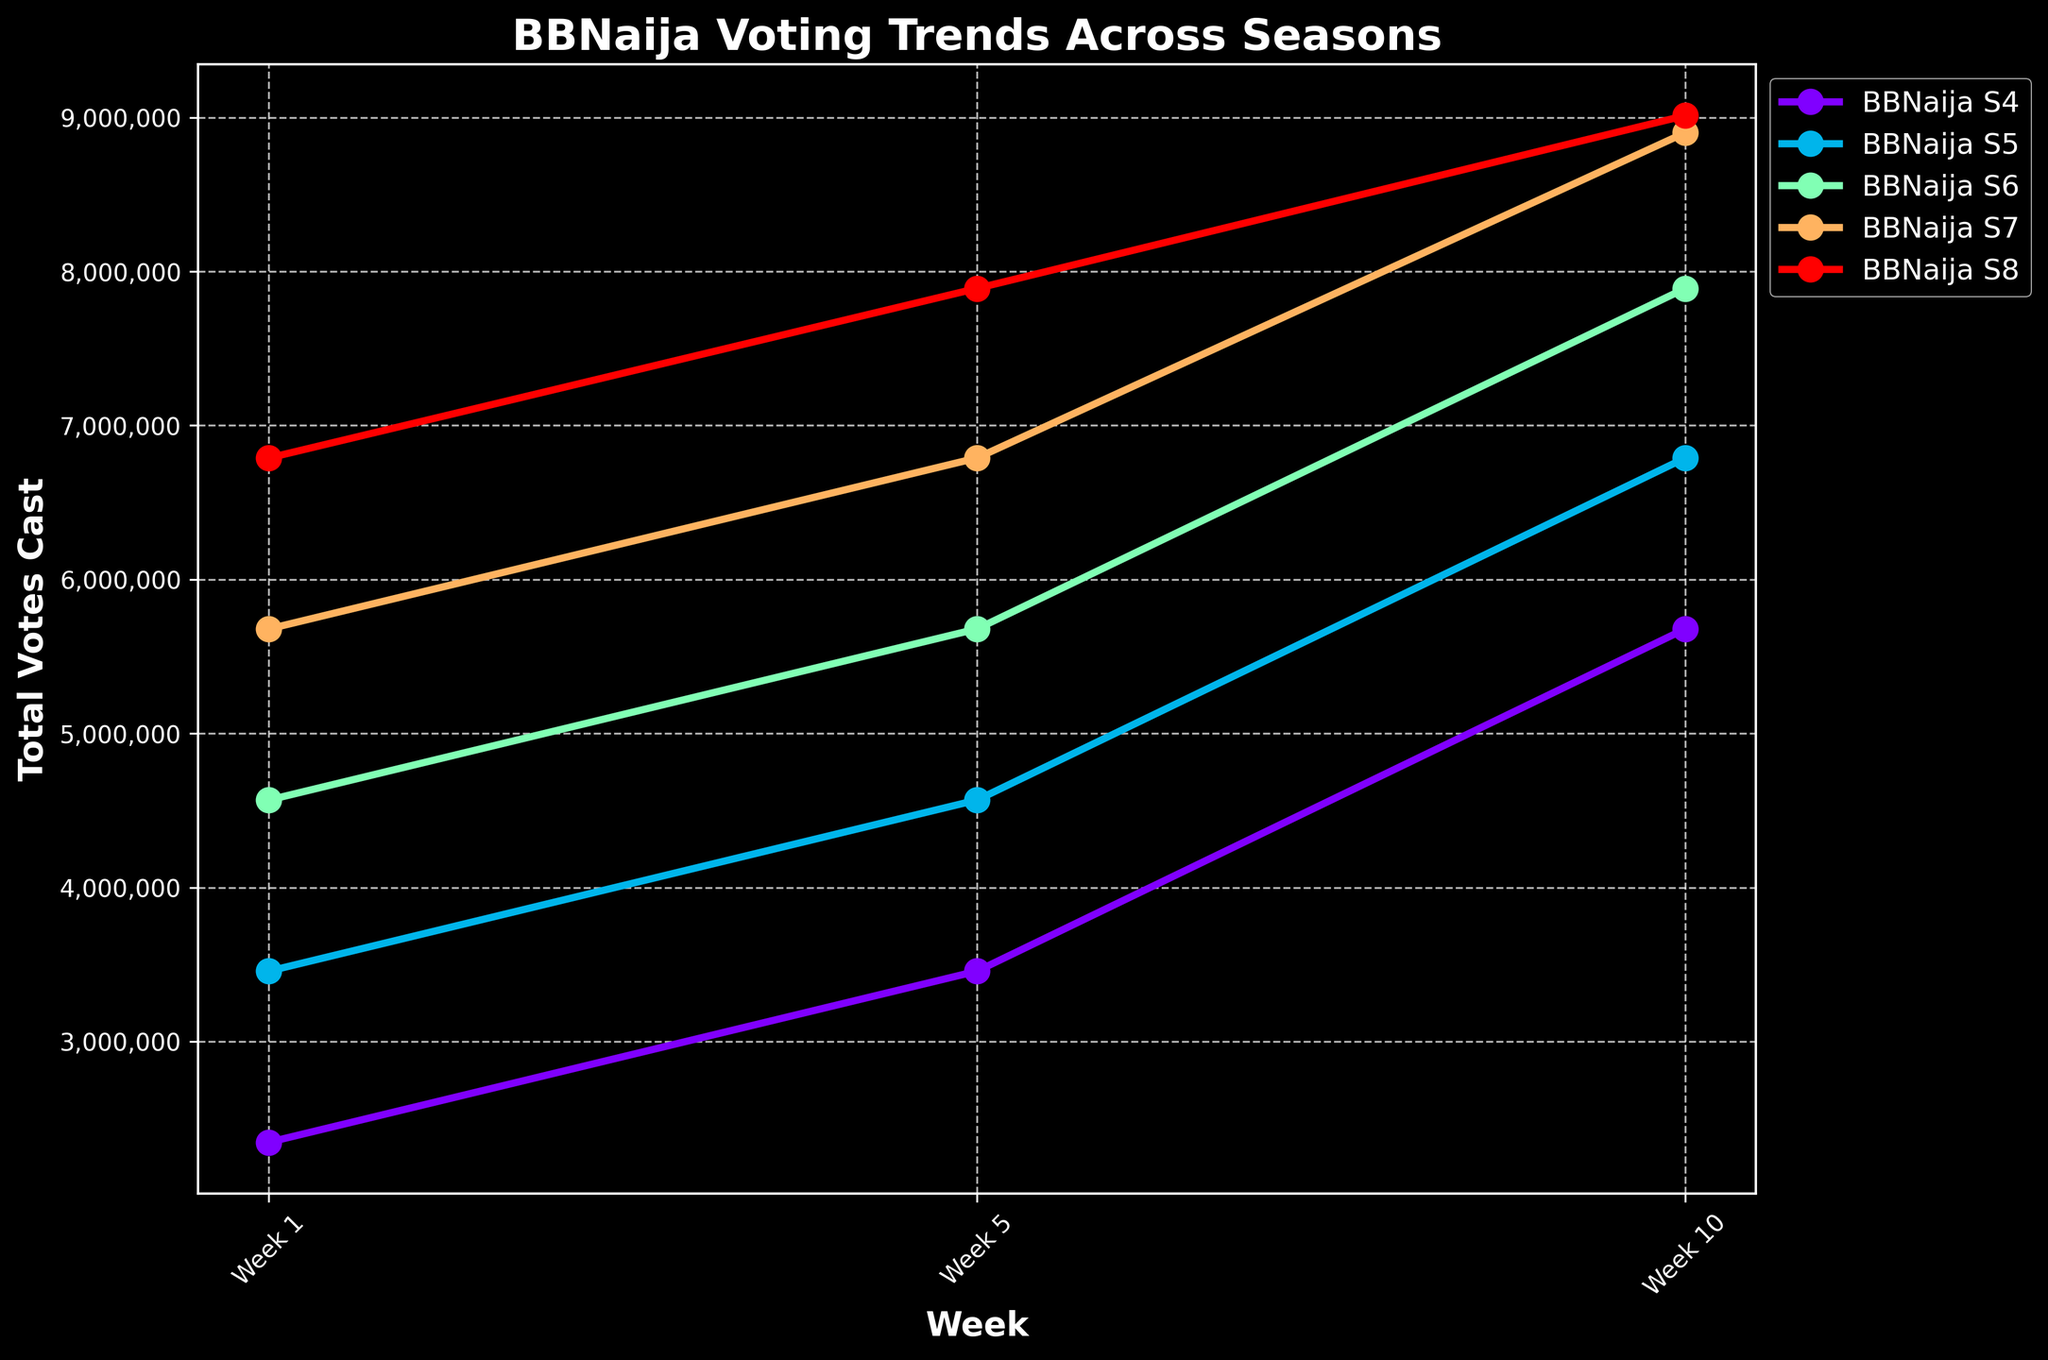Which season had the highest total votes cast in Week 10? To find this, look at the Week 10 data for each season and compare the values. BBNaija S8 has the highest value of 9,012,345.
Answer: BBNaija S8 How did the total votes cast in BBNaija S5 change from Week 5 to Week 10? Subtract the total votes in Week 5 from the total votes in Week 10 for BBNaija S5: 6,789,012 - 4,567,890 = 2,221,122.
Answer: Increased by 2,221,122 What is the trend in the total votes cast across all seasons from Week 1 to Week 10? Generally, the total votes cast increase from Week 1 to Week 10 in all seasons. This is observed in all the plotted lines rising as they progress from Week 1 to Week 10.
Answer: Increasing Which season had the smallest increase in total votes cast from Week 1 to Week 10? Calculate the increase for each season by subtracting the value in Week 1 from the value in Week 10. BBNaija S4: 5,678,901 - 2,345,678 = 3,333,223; BBNaija S5: 6,789,012 - 3,456,789 = 3,332,223; BBNaija S6: 7,890,123 - 4,567,890 = 3,322,233; BBNaija S7: 8,901,234 - 5,678,901 = 3,222,333; BBNaija S8: 9,012,345 - 6,789,012 = 3,223,333. BBNaija S7 had the smallest increase (3,222,333).
Answer: BBNaija S7 Compare the total votes cast in Week 5 between BBNaija S6 and BBNaija S8. Which one had more votes? Look at the total votes cast in Week 5 for both BBNaija S6 (5,678,901) and BBNaija S8 (7,890,123). BBNaija S8 had more votes.
Answer: BBNaija S8 What is the median of total votes cast in Week 1 across all seasons? The total votes cast in Week 1 across all seasons are: 2,345,678, 3,456,789, 4,567,890, 5,678,901, 6,789,012. Arrange them in ascending order: 2,345,678, 3,456,789, 4,567,890, 5,678,901, 6,789,012. The median is the middle value, 4,567,890.
Answer: 4,567,890 How many more votes were cast in Week 10 of BBNaija S8 compared to BBNaija S4? Subtract the votes cast in Week 10 of BBNaija S4 from BBNaija S8: 9,012,345 - 5,678,901 = 3,333,444.
Answer: 3,333,444 Which week(s) had the highest total votes cast in BBNaija S7? Look at the data points for BBNaija S7: Week 1 (5,678,901), Week 5 (6,789,012), Week 10 (8,901,234). Week 10 had the highest votes cast.
Answer: Week 10 